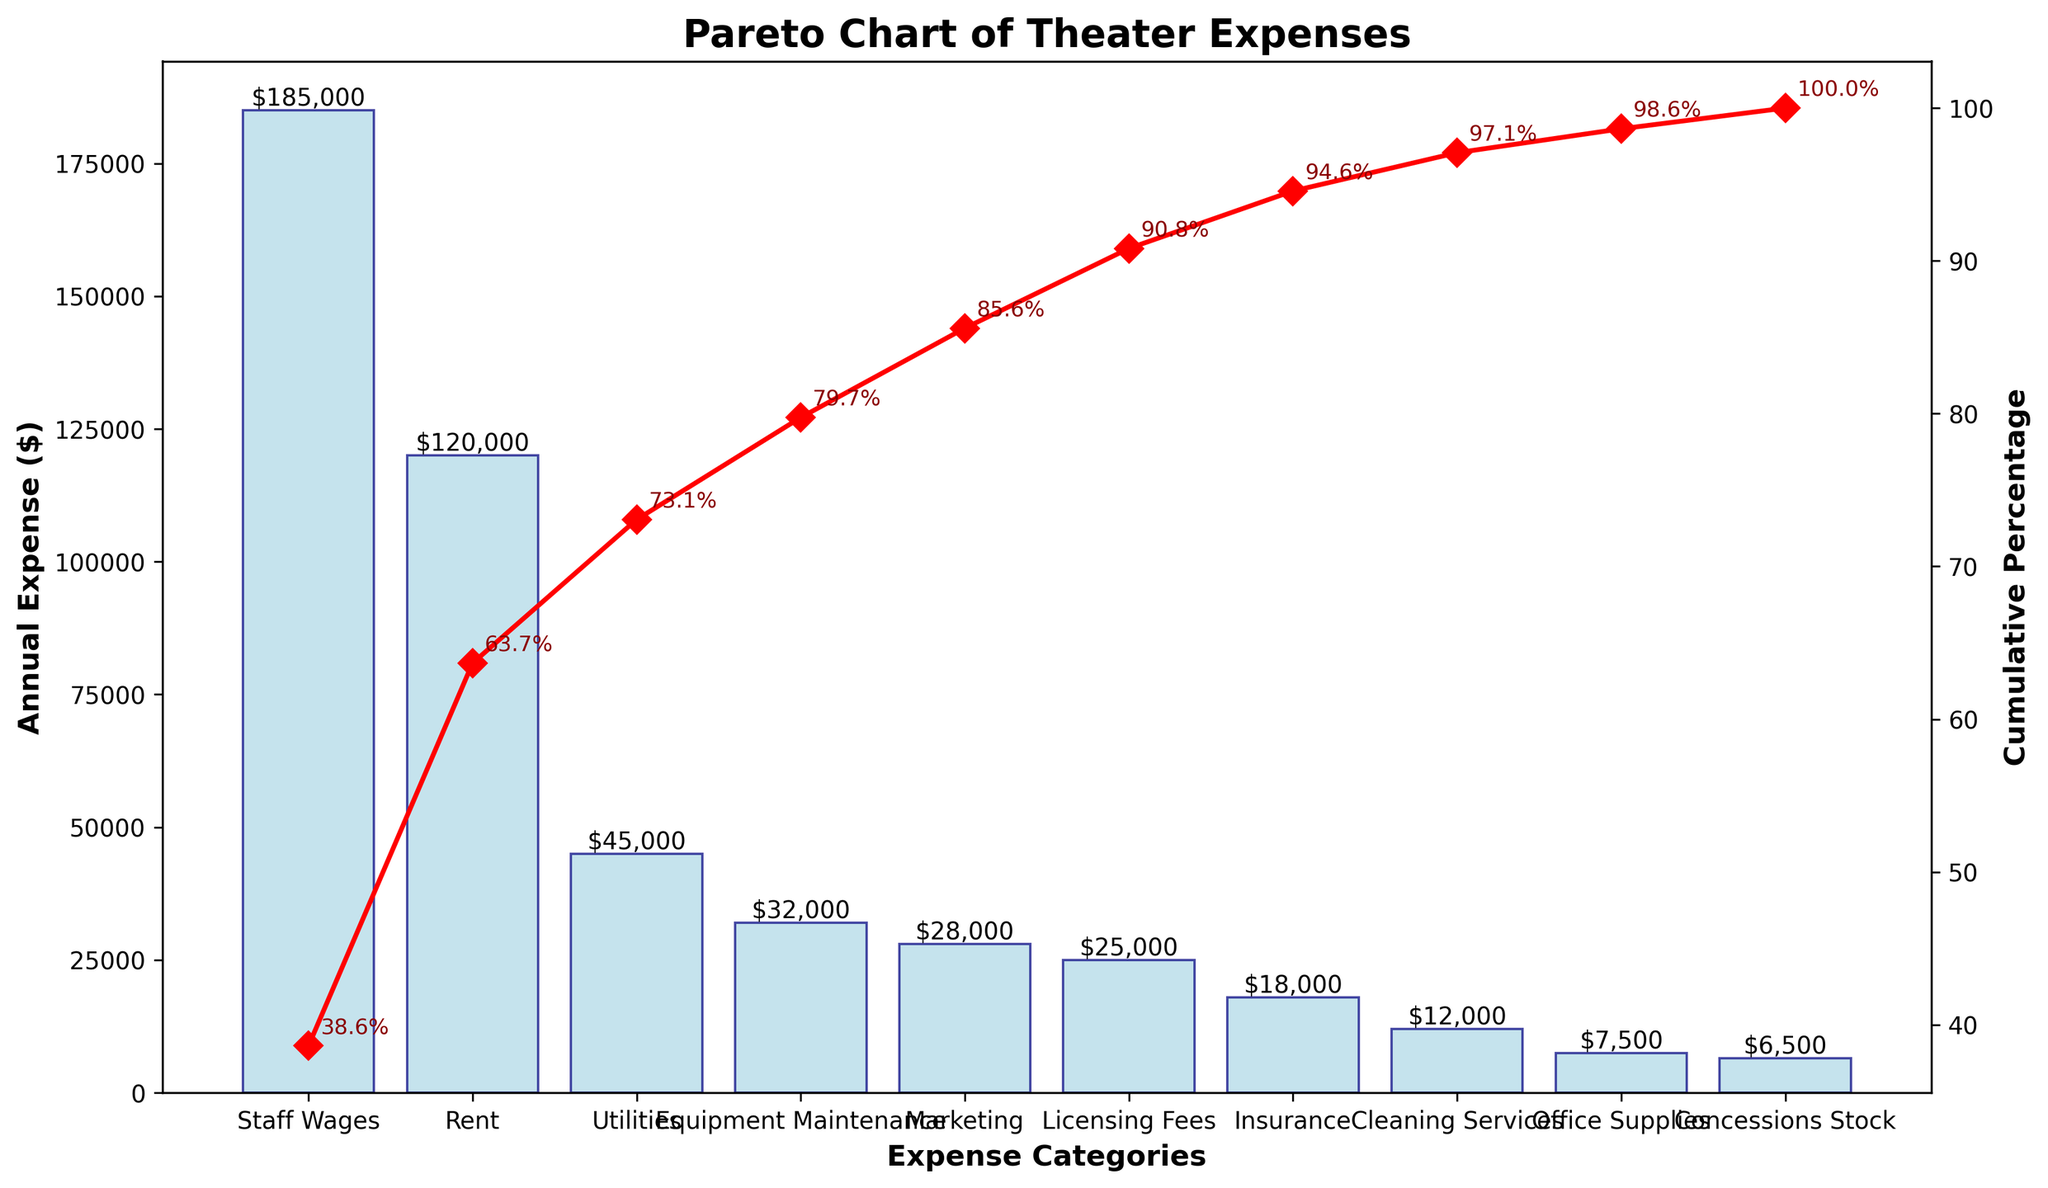What is the highest annual expense category for theater operations? The highest bar represents the highest annual expense category. "Staff Wages" has the tallest bar and the highest dollar amount.
Answer: Staff Wages How much is spent annually on rent? Locate the bar labeled "Rent" and read off the value on the y-axis. The value is $120,000.
Answer: $120,000 What percentage of the total annual expense is represented by staff wages and rent combined? Add the expenses for "Staff Wages" ($185,000) and "Rent" ($120,000) to get a total of $305,000. Divide $305,000 by the total of all expenses ($480,000) and multiply by 100 to get the percentage.
Answer: 63.5% Which expense categories account for over 60% of the total annual expenses? Identify the categories with a cumulative percentage up to just past 60%. "Staff Wages," "Rent," and "Utilities" cumulatively account for over 60%.
Answer: Staff Wages, Rent, Utilities By how much do marketing expenses exceed insurance expenses annually? Locate the bars for "Marketing" and "Insurance" and subtract the smaller expense ($18,000 for Insurance) from the larger expense ($28,000 for Marketing).
Answer: $10,000 What is the cumulative percentage for the category "Utilities"? Find the point on the cumulative percentage line corresponding to the "Utilities" category. The value is 73.4%.
Answer: 73.4% What is the fourth most expensive category? Identify the fourth highest bar. "Equipment Maintenance" is the fourth most expensive category.
Answer: Equipment Maintenance Which has a higher annual expense: marketing or licensing fees? Compare the heights of the bars for "Marketing" ($28,000) and "Licensing Fees" ($25,000). Marketing is higher.
Answer: Marketing How many categories have annual expenses below $20,000? Count the number of bars whose values are below $20,000. There are four such categories.
Answer: 4 Do marketing and cleaning services combined exceed utilities in annual expenses? Add the expenses for "Marketing" ($28,000) and "Cleaning Services" ($12,000) to get a total of $40,000. Compare this to the "Utilities" expense of $45,000. The combined value is less.
Answer: No 